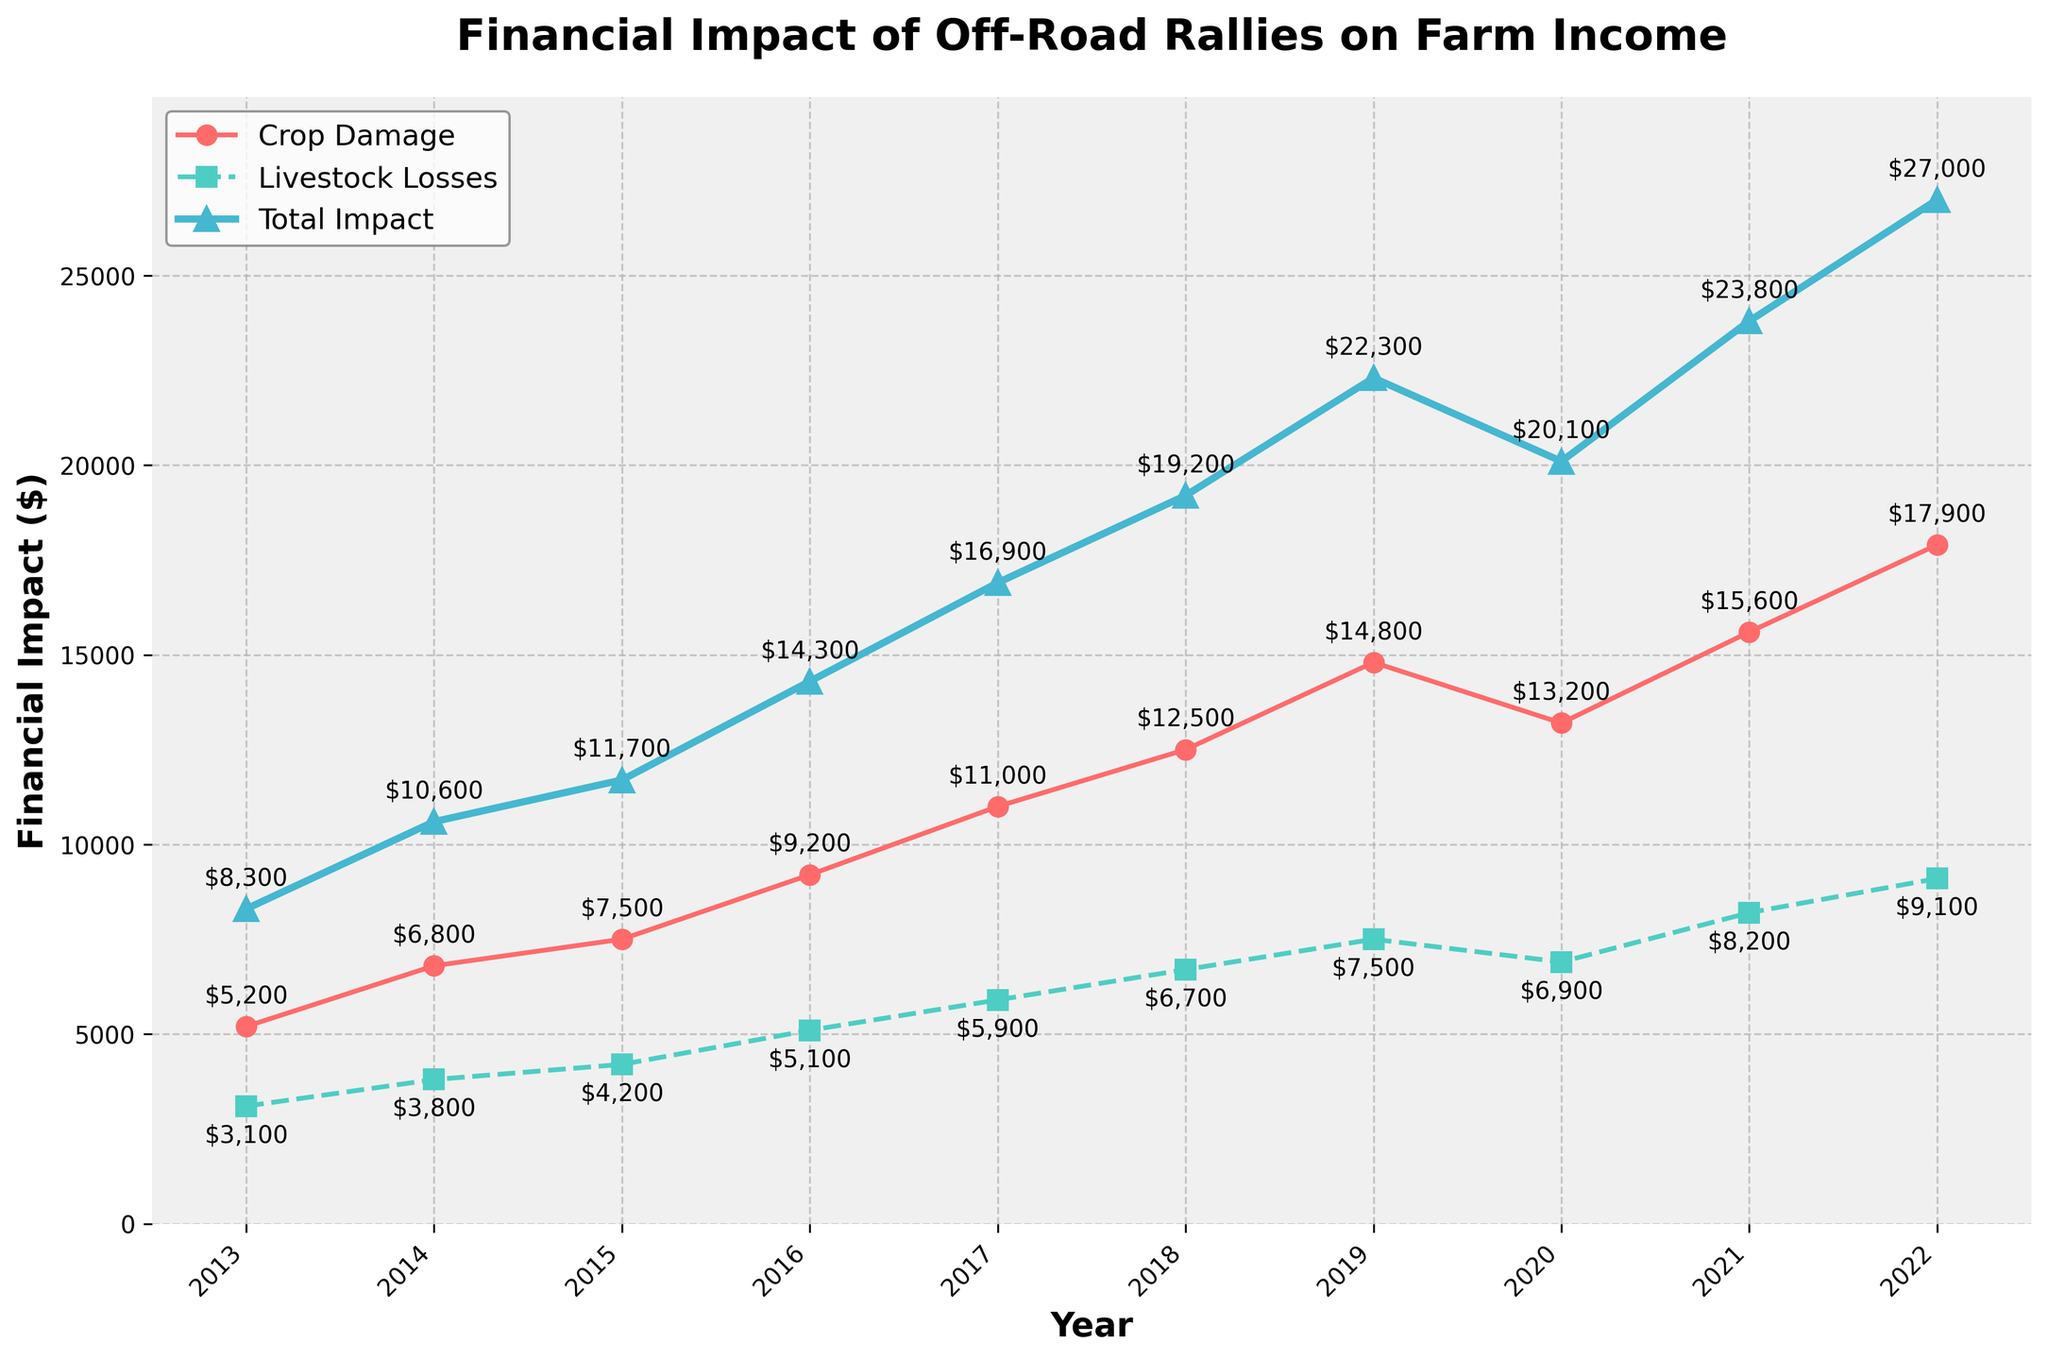What was the financial impact from crop damage in 2016? Looking at the line representing crop damage costs for the year 2016, it reaches $9,200.
Answer: $9,200 Which year had the highest livestock stress-related losses? By observing the peaks of the line for livestock stress-related losses, 2022 shows the highest loss at $9,100.
Answer: 2022 How much did the total financial impact increase from 2013 to 2022? Subtract the total impact in 2013 ($8,300) from the total in 2022 ($27,000). Calculation: $27,000 - $8,300 = $18,700.
Answer: $18,700 What is the difference between crop damage costs and livestock stress-related losses in 2021? Subtract the livestock losses in 2021 ($8,200) from the crop damage costs in 2021 ($15,600). Calculation: $15,600 - $8,200 = $7,400.
Answer: $7,400 In which year did the financial impact for livestock stress-related losses first exceed $5,000? Follow the line for livestock losses and identify 2016 where it first exceeds $5,000 at $5,100.
Answer: 2016 Between which consecutive years did the total financial impact increase the most? Assess the year-on-year changes in the total financial impact line. The largest jump happened between 2018 ($19,200) and 2019 ($22,300). Calculation: $22,300 - $19,200 = $3,100.
Answer: 2018 to 2019 Compare the crop damage costs in 2015 and 2019. Which year had higher costs? Compare the points for crop damage in 2015 ($7,500) and 2019 ($14,800). 2019 is higher.
Answer: 2019 What is the average livestock stress-related loss over the decade? Sum the yearly livestock losses and divide by 10. Calculation: ($3,100 + $3,800 + $4,200 + $5,100 + $5,900 + $6,700 + $7,500 + $6,900 + $8,200 + $9,100) = $60,500. Average = $60,500 / 10 = $6,050.
Answer: $6,050 